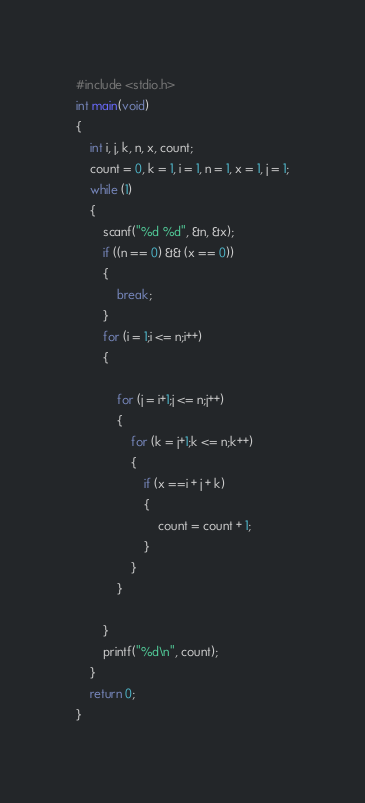Convert code to text. <code><loc_0><loc_0><loc_500><loc_500><_C_>#include <stdio.h> 
int main(void)
{
	int i, j, k, n, x, count;
	count = 0, k = 1, i = 1, n = 1, x = 1, j = 1;
	while (1)
	{
		scanf("%d %d", &n, &x);
		if ((n == 0) && (x == 0))
		{
			break;
		}
		for (i = 1;i <= n;i++)
		{
			
			for (j = i+1;j <= n;j++)
			{
				for (k = j+1;k <= n;k++)
				{
					if (x ==i + j + k)
					{
						count = count + 1;
					}
				}
			}

		}
		printf("%d\n", count);
	}
	return 0;
}</code> 